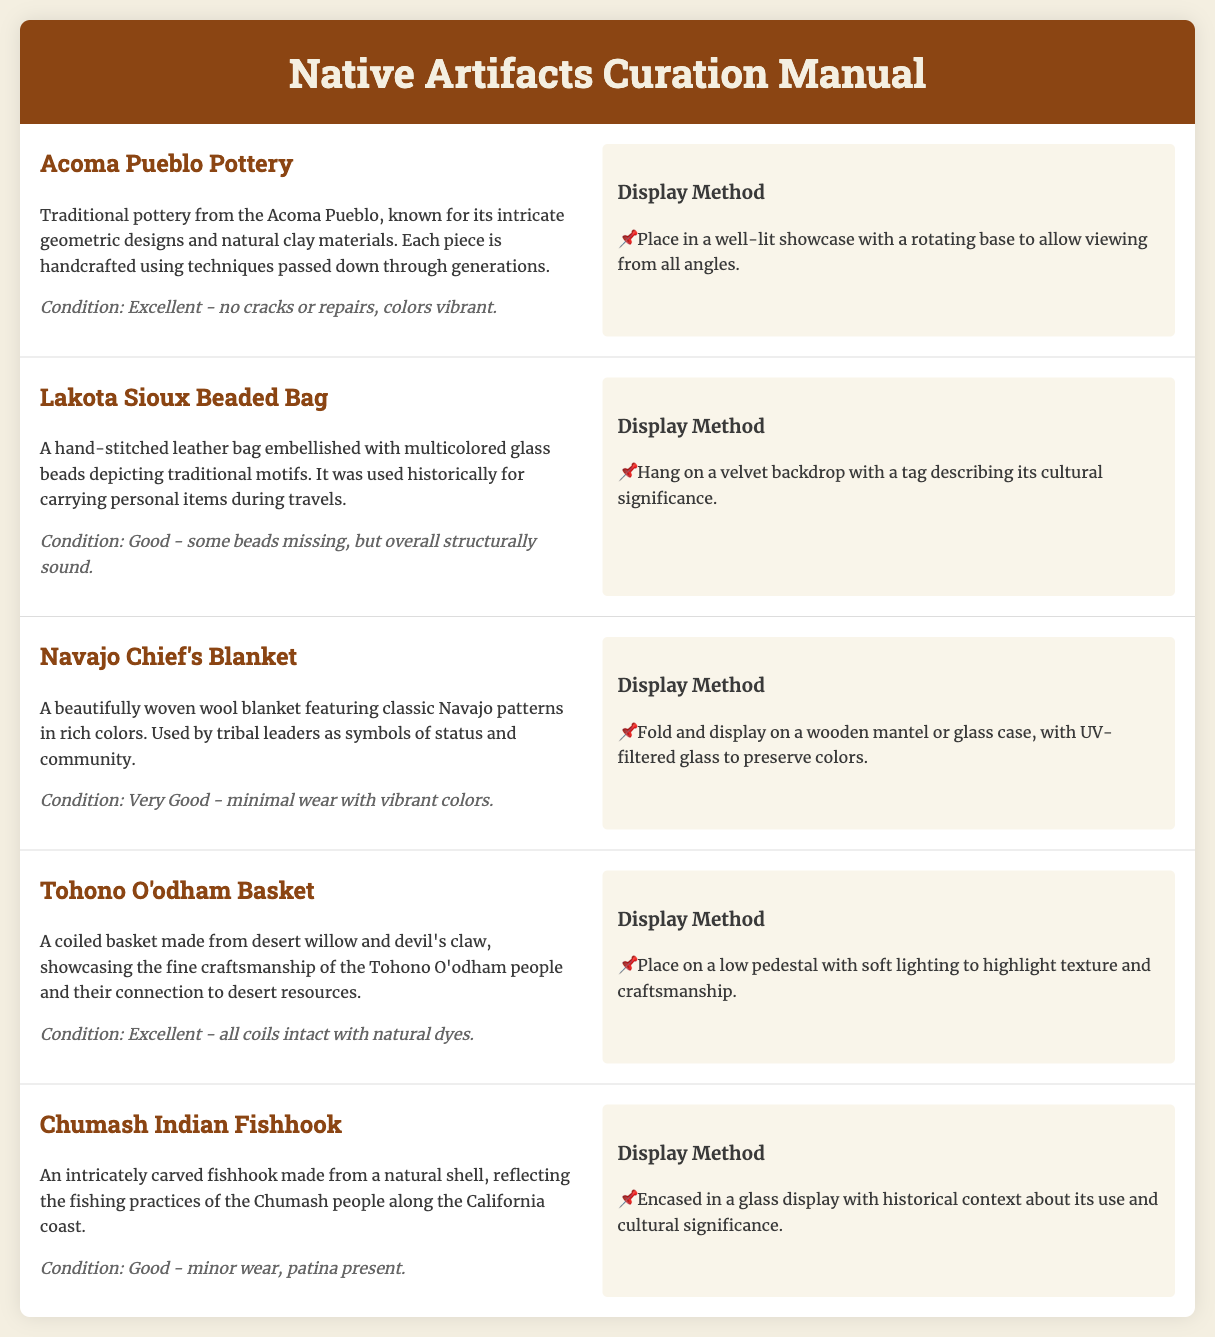What is the first artifact listed? The first artifact mentioned in the document is the Acoma Pueblo Pottery, which is described with its features and condition.
Answer: Acoma Pueblo Pottery What is the condition of the Lakota Sioux Beaded Bag? The Lakota Sioux Beaded Bag's condition is specified as good, mentioning some missing beads but overall structural soundness.
Answer: Good Which material is the Tohono O'odham Basket made from? The document states that the Tohono O'odham Basket is made from desert willow and devil's claw, highlighting its craftsmanship and materials.
Answer: Desert willow and devil's claw How should the Navajo Chief's Blanket be displayed? The suggested display method for the Navajo Chief's Blanket involves folding it and placing it on a wooden mantel or glass case.
Answer: Fold and display on a wooden mantel or glass case What cultural significance does the Chumash Indian Fishhook represent? The Chumash Indian Fishhook reflects the fishing practices of the Chumash people along the California coast, which is noted in its description.
Answer: Fishing practices of the Chumash people Which artifact is described as having intricate geometric designs? The document describes the Acoma Pueblo Pottery as having intricate geometric designs, which is a significant feature of this artifact.
Answer: Acoma Pueblo Pottery How does the manual suggest lighting for the Tohono O'odham Basket? The display method for the Tohono O'odham Basket mentions using soft lighting to highlight its texture and craftsmanship.
Answer: Soft lighting What is the primary purpose of the display methods outlined in the document? The display methods aim to enhance the visibility and appreciation of each artifact's cultural significance and craftsmanship.
Answer: Enhance visibility and appreciation 